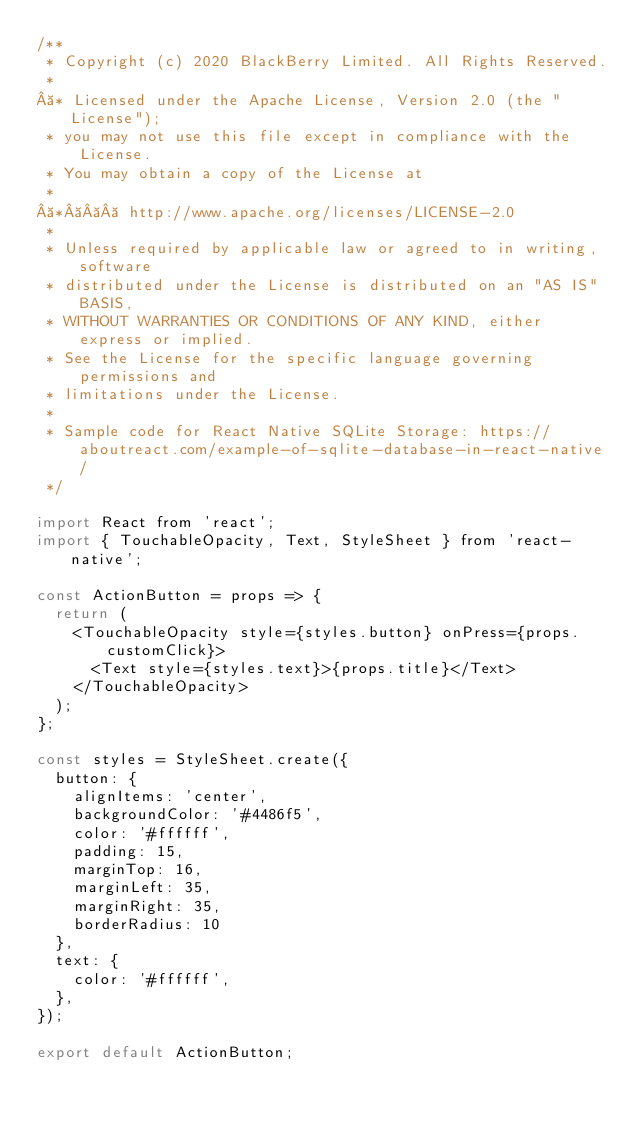Convert code to text. <code><loc_0><loc_0><loc_500><loc_500><_JavaScript_>/**
 * Copyright (c) 2020 BlackBerry Limited. All Rights Reserved.
 *
 * Licensed under the Apache License, Version 2.0 (the "License");
 * you may not use this file except in compliance with the License.
 * You may obtain a copy of the License at
 *
 *    http://www.apache.org/licenses/LICENSE-2.0
 *
 * Unless required by applicable law or agreed to in writing, software
 * distributed under the License is distributed on an "AS IS" BASIS,
 * WITHOUT WARRANTIES OR CONDITIONS OF ANY KIND, either express or implied.
 * See the License for the specific language governing permissions and
 * limitations under the License.
 *
 * Sample code for React Native SQLite Storage: https://aboutreact.com/example-of-sqlite-database-in-react-native/ 
 */
 
import React from 'react';
import { TouchableOpacity, Text, StyleSheet } from 'react-native';

const ActionButton = props => {
  return (
    <TouchableOpacity style={styles.button} onPress={props.customClick}>
      <Text style={styles.text}>{props.title}</Text>
    </TouchableOpacity>
  );
};

const styles = StyleSheet.create({
  button: {
    alignItems: 'center',
    backgroundColor: '#4486f5',
    color: '#ffffff',
    padding: 15,
    marginTop: 16,
    marginLeft: 35,
    marginRight: 35,
    borderRadius: 10
  },
  text: {
    color: '#ffffff',
  },
});

export default ActionButton;
</code> 